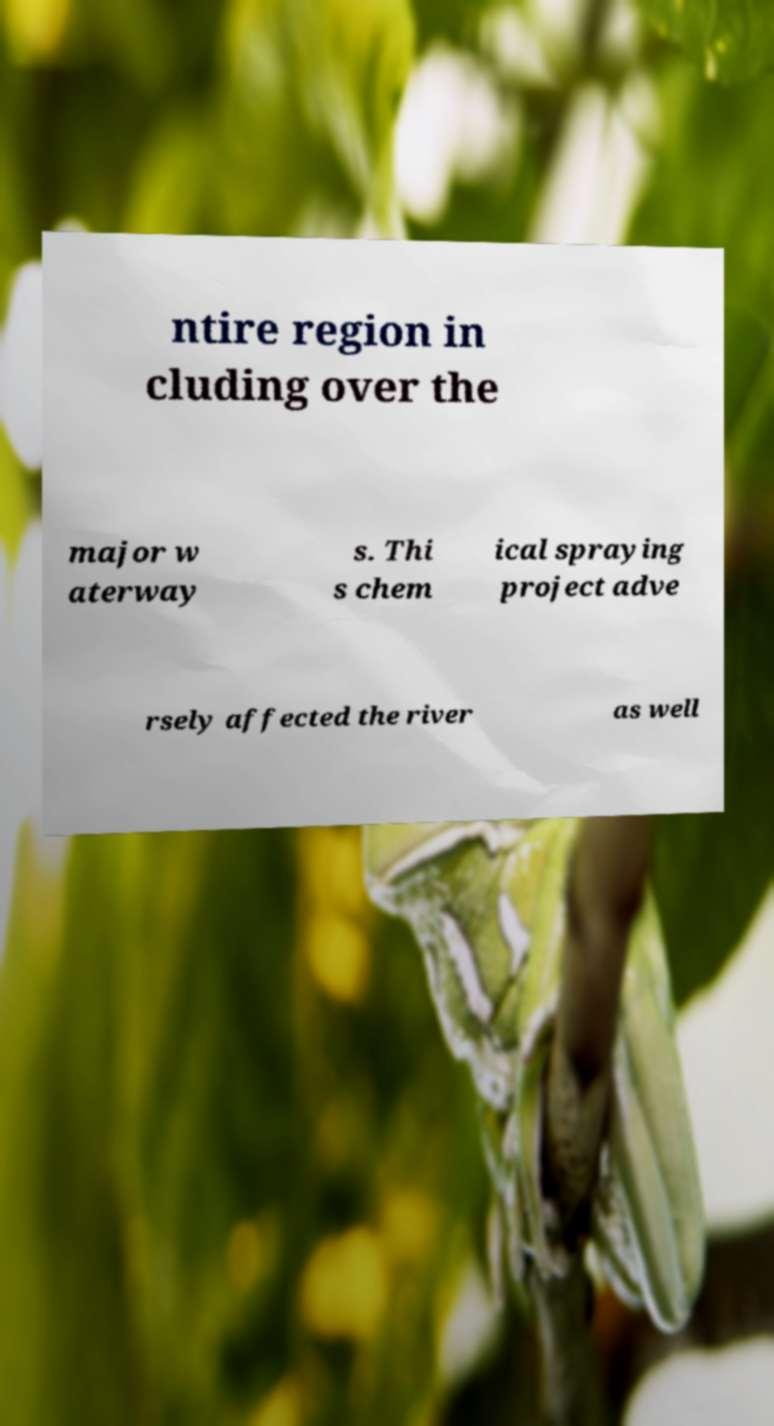Can you read and provide the text displayed in the image?This photo seems to have some interesting text. Can you extract and type it out for me? ntire region in cluding over the major w aterway s. Thi s chem ical spraying project adve rsely affected the river as well 